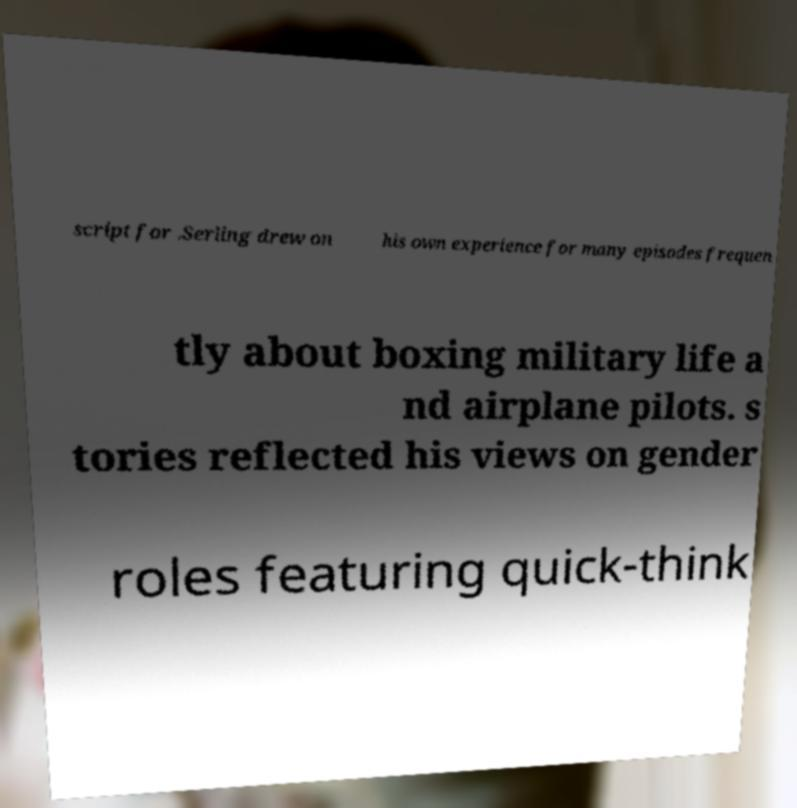What messages or text are displayed in this image? I need them in a readable, typed format. script for .Serling drew on his own experience for many episodes frequen tly about boxing military life a nd airplane pilots. s tories reflected his views on gender roles featuring quick-think 